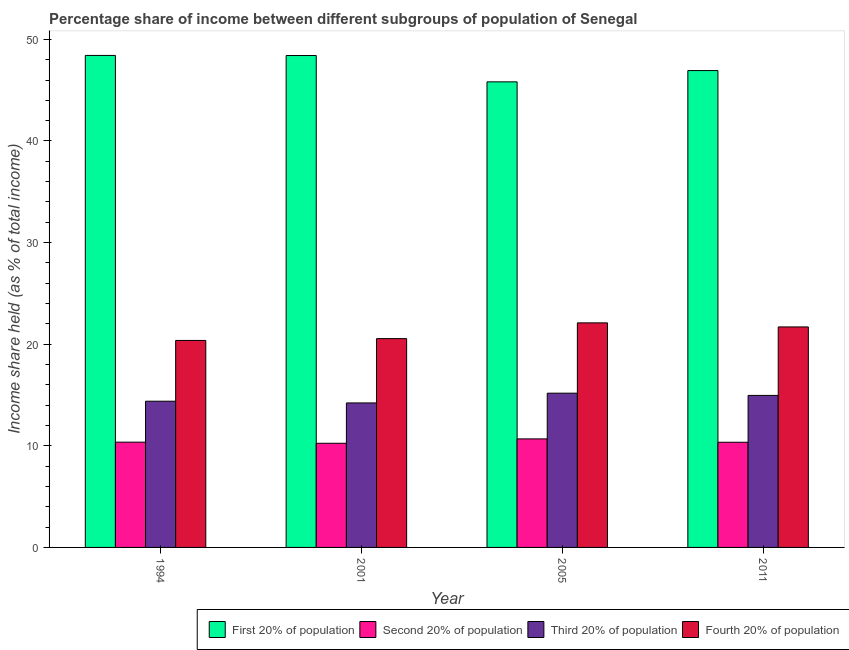How many different coloured bars are there?
Provide a short and direct response. 4. How many groups of bars are there?
Your answer should be compact. 4. Are the number of bars on each tick of the X-axis equal?
Ensure brevity in your answer.  Yes. How many bars are there on the 3rd tick from the left?
Make the answer very short. 4. How many bars are there on the 2nd tick from the right?
Your answer should be compact. 4. What is the label of the 3rd group of bars from the left?
Offer a very short reply. 2005. In how many cases, is the number of bars for a given year not equal to the number of legend labels?
Keep it short and to the point. 0. What is the share of the income held by fourth 20% of the population in 2001?
Give a very brief answer. 20.55. Across all years, what is the maximum share of the income held by second 20% of the population?
Ensure brevity in your answer.  10.68. Across all years, what is the minimum share of the income held by first 20% of the population?
Provide a succinct answer. 45.82. What is the total share of the income held by fourth 20% of the population in the graph?
Your answer should be compact. 84.72. What is the difference between the share of the income held by third 20% of the population in 1994 and that in 2005?
Provide a short and direct response. -0.79. What is the difference between the share of the income held by fourth 20% of the population in 2005 and the share of the income held by first 20% of the population in 2011?
Your answer should be very brief. 0.4. What is the average share of the income held by second 20% of the population per year?
Provide a succinct answer. 10.41. In how many years, is the share of the income held by first 20% of the population greater than 38 %?
Provide a succinct answer. 4. What is the ratio of the share of the income held by fourth 20% of the population in 1994 to that in 2005?
Provide a short and direct response. 0.92. Is the share of the income held by fourth 20% of the population in 1994 less than that in 2005?
Ensure brevity in your answer.  Yes. What is the difference between the highest and the second highest share of the income held by first 20% of the population?
Your response must be concise. 0.01. What is the difference between the highest and the lowest share of the income held by fourth 20% of the population?
Your answer should be very brief. 1.73. Is it the case that in every year, the sum of the share of the income held by first 20% of the population and share of the income held by third 20% of the population is greater than the sum of share of the income held by fourth 20% of the population and share of the income held by second 20% of the population?
Offer a very short reply. Yes. What does the 1st bar from the left in 1994 represents?
Make the answer very short. First 20% of population. What does the 4th bar from the right in 1994 represents?
Give a very brief answer. First 20% of population. What is the difference between two consecutive major ticks on the Y-axis?
Make the answer very short. 10. Are the values on the major ticks of Y-axis written in scientific E-notation?
Provide a short and direct response. No. Does the graph contain grids?
Ensure brevity in your answer.  No. What is the title of the graph?
Provide a succinct answer. Percentage share of income between different subgroups of population of Senegal. Does "UNTA" appear as one of the legend labels in the graph?
Keep it short and to the point. No. What is the label or title of the Y-axis?
Provide a succinct answer. Income share held (as % of total income). What is the Income share held (as % of total income) in First 20% of population in 1994?
Make the answer very short. 48.42. What is the Income share held (as % of total income) in Second 20% of population in 1994?
Offer a terse response. 10.36. What is the Income share held (as % of total income) of Third 20% of population in 1994?
Your answer should be compact. 14.39. What is the Income share held (as % of total income) in Fourth 20% of population in 1994?
Your answer should be very brief. 20.37. What is the Income share held (as % of total income) of First 20% of population in 2001?
Your answer should be compact. 48.41. What is the Income share held (as % of total income) of Second 20% of population in 2001?
Offer a very short reply. 10.25. What is the Income share held (as % of total income) in Third 20% of population in 2001?
Give a very brief answer. 14.22. What is the Income share held (as % of total income) of Fourth 20% of population in 2001?
Your answer should be very brief. 20.55. What is the Income share held (as % of total income) of First 20% of population in 2005?
Provide a short and direct response. 45.82. What is the Income share held (as % of total income) of Second 20% of population in 2005?
Ensure brevity in your answer.  10.68. What is the Income share held (as % of total income) in Third 20% of population in 2005?
Offer a very short reply. 15.18. What is the Income share held (as % of total income) of Fourth 20% of population in 2005?
Ensure brevity in your answer.  22.1. What is the Income share held (as % of total income) in First 20% of population in 2011?
Provide a short and direct response. 46.93. What is the Income share held (as % of total income) in Second 20% of population in 2011?
Provide a succinct answer. 10.35. What is the Income share held (as % of total income) in Third 20% of population in 2011?
Your answer should be compact. 14.96. What is the Income share held (as % of total income) of Fourth 20% of population in 2011?
Offer a very short reply. 21.7. Across all years, what is the maximum Income share held (as % of total income) in First 20% of population?
Give a very brief answer. 48.42. Across all years, what is the maximum Income share held (as % of total income) of Second 20% of population?
Provide a succinct answer. 10.68. Across all years, what is the maximum Income share held (as % of total income) in Third 20% of population?
Your answer should be compact. 15.18. Across all years, what is the maximum Income share held (as % of total income) in Fourth 20% of population?
Your response must be concise. 22.1. Across all years, what is the minimum Income share held (as % of total income) of First 20% of population?
Provide a succinct answer. 45.82. Across all years, what is the minimum Income share held (as % of total income) of Second 20% of population?
Provide a succinct answer. 10.25. Across all years, what is the minimum Income share held (as % of total income) of Third 20% of population?
Give a very brief answer. 14.22. Across all years, what is the minimum Income share held (as % of total income) in Fourth 20% of population?
Keep it short and to the point. 20.37. What is the total Income share held (as % of total income) of First 20% of population in the graph?
Offer a very short reply. 189.58. What is the total Income share held (as % of total income) of Second 20% of population in the graph?
Give a very brief answer. 41.64. What is the total Income share held (as % of total income) of Third 20% of population in the graph?
Your response must be concise. 58.75. What is the total Income share held (as % of total income) of Fourth 20% of population in the graph?
Your answer should be compact. 84.72. What is the difference between the Income share held (as % of total income) in Second 20% of population in 1994 and that in 2001?
Provide a succinct answer. 0.11. What is the difference between the Income share held (as % of total income) in Third 20% of population in 1994 and that in 2001?
Your response must be concise. 0.17. What is the difference between the Income share held (as % of total income) of Fourth 20% of population in 1994 and that in 2001?
Keep it short and to the point. -0.18. What is the difference between the Income share held (as % of total income) in First 20% of population in 1994 and that in 2005?
Give a very brief answer. 2.6. What is the difference between the Income share held (as % of total income) in Second 20% of population in 1994 and that in 2005?
Keep it short and to the point. -0.32. What is the difference between the Income share held (as % of total income) in Third 20% of population in 1994 and that in 2005?
Offer a very short reply. -0.79. What is the difference between the Income share held (as % of total income) of Fourth 20% of population in 1994 and that in 2005?
Your response must be concise. -1.73. What is the difference between the Income share held (as % of total income) of First 20% of population in 1994 and that in 2011?
Offer a very short reply. 1.49. What is the difference between the Income share held (as % of total income) in Second 20% of population in 1994 and that in 2011?
Ensure brevity in your answer.  0.01. What is the difference between the Income share held (as % of total income) in Third 20% of population in 1994 and that in 2011?
Keep it short and to the point. -0.57. What is the difference between the Income share held (as % of total income) of Fourth 20% of population in 1994 and that in 2011?
Make the answer very short. -1.33. What is the difference between the Income share held (as % of total income) in First 20% of population in 2001 and that in 2005?
Your answer should be compact. 2.59. What is the difference between the Income share held (as % of total income) in Second 20% of population in 2001 and that in 2005?
Provide a short and direct response. -0.43. What is the difference between the Income share held (as % of total income) in Third 20% of population in 2001 and that in 2005?
Offer a terse response. -0.96. What is the difference between the Income share held (as % of total income) of Fourth 20% of population in 2001 and that in 2005?
Provide a succinct answer. -1.55. What is the difference between the Income share held (as % of total income) in First 20% of population in 2001 and that in 2011?
Offer a very short reply. 1.48. What is the difference between the Income share held (as % of total income) of Second 20% of population in 2001 and that in 2011?
Offer a very short reply. -0.1. What is the difference between the Income share held (as % of total income) in Third 20% of population in 2001 and that in 2011?
Ensure brevity in your answer.  -0.74. What is the difference between the Income share held (as % of total income) in Fourth 20% of population in 2001 and that in 2011?
Your response must be concise. -1.15. What is the difference between the Income share held (as % of total income) in First 20% of population in 2005 and that in 2011?
Offer a terse response. -1.11. What is the difference between the Income share held (as % of total income) of Second 20% of population in 2005 and that in 2011?
Provide a succinct answer. 0.33. What is the difference between the Income share held (as % of total income) of Third 20% of population in 2005 and that in 2011?
Your response must be concise. 0.22. What is the difference between the Income share held (as % of total income) of First 20% of population in 1994 and the Income share held (as % of total income) of Second 20% of population in 2001?
Keep it short and to the point. 38.17. What is the difference between the Income share held (as % of total income) in First 20% of population in 1994 and the Income share held (as % of total income) in Third 20% of population in 2001?
Your answer should be very brief. 34.2. What is the difference between the Income share held (as % of total income) in First 20% of population in 1994 and the Income share held (as % of total income) in Fourth 20% of population in 2001?
Offer a very short reply. 27.87. What is the difference between the Income share held (as % of total income) in Second 20% of population in 1994 and the Income share held (as % of total income) in Third 20% of population in 2001?
Your answer should be compact. -3.86. What is the difference between the Income share held (as % of total income) in Second 20% of population in 1994 and the Income share held (as % of total income) in Fourth 20% of population in 2001?
Provide a short and direct response. -10.19. What is the difference between the Income share held (as % of total income) of Third 20% of population in 1994 and the Income share held (as % of total income) of Fourth 20% of population in 2001?
Make the answer very short. -6.16. What is the difference between the Income share held (as % of total income) of First 20% of population in 1994 and the Income share held (as % of total income) of Second 20% of population in 2005?
Your answer should be very brief. 37.74. What is the difference between the Income share held (as % of total income) of First 20% of population in 1994 and the Income share held (as % of total income) of Third 20% of population in 2005?
Give a very brief answer. 33.24. What is the difference between the Income share held (as % of total income) of First 20% of population in 1994 and the Income share held (as % of total income) of Fourth 20% of population in 2005?
Your answer should be compact. 26.32. What is the difference between the Income share held (as % of total income) of Second 20% of population in 1994 and the Income share held (as % of total income) of Third 20% of population in 2005?
Offer a terse response. -4.82. What is the difference between the Income share held (as % of total income) in Second 20% of population in 1994 and the Income share held (as % of total income) in Fourth 20% of population in 2005?
Offer a terse response. -11.74. What is the difference between the Income share held (as % of total income) of Third 20% of population in 1994 and the Income share held (as % of total income) of Fourth 20% of population in 2005?
Your answer should be very brief. -7.71. What is the difference between the Income share held (as % of total income) of First 20% of population in 1994 and the Income share held (as % of total income) of Second 20% of population in 2011?
Your response must be concise. 38.07. What is the difference between the Income share held (as % of total income) of First 20% of population in 1994 and the Income share held (as % of total income) of Third 20% of population in 2011?
Give a very brief answer. 33.46. What is the difference between the Income share held (as % of total income) of First 20% of population in 1994 and the Income share held (as % of total income) of Fourth 20% of population in 2011?
Make the answer very short. 26.72. What is the difference between the Income share held (as % of total income) in Second 20% of population in 1994 and the Income share held (as % of total income) in Fourth 20% of population in 2011?
Provide a short and direct response. -11.34. What is the difference between the Income share held (as % of total income) of Third 20% of population in 1994 and the Income share held (as % of total income) of Fourth 20% of population in 2011?
Provide a succinct answer. -7.31. What is the difference between the Income share held (as % of total income) of First 20% of population in 2001 and the Income share held (as % of total income) of Second 20% of population in 2005?
Ensure brevity in your answer.  37.73. What is the difference between the Income share held (as % of total income) of First 20% of population in 2001 and the Income share held (as % of total income) of Third 20% of population in 2005?
Provide a short and direct response. 33.23. What is the difference between the Income share held (as % of total income) of First 20% of population in 2001 and the Income share held (as % of total income) of Fourth 20% of population in 2005?
Your answer should be compact. 26.31. What is the difference between the Income share held (as % of total income) of Second 20% of population in 2001 and the Income share held (as % of total income) of Third 20% of population in 2005?
Ensure brevity in your answer.  -4.93. What is the difference between the Income share held (as % of total income) in Second 20% of population in 2001 and the Income share held (as % of total income) in Fourth 20% of population in 2005?
Your answer should be compact. -11.85. What is the difference between the Income share held (as % of total income) in Third 20% of population in 2001 and the Income share held (as % of total income) in Fourth 20% of population in 2005?
Offer a very short reply. -7.88. What is the difference between the Income share held (as % of total income) in First 20% of population in 2001 and the Income share held (as % of total income) in Second 20% of population in 2011?
Offer a very short reply. 38.06. What is the difference between the Income share held (as % of total income) in First 20% of population in 2001 and the Income share held (as % of total income) in Third 20% of population in 2011?
Ensure brevity in your answer.  33.45. What is the difference between the Income share held (as % of total income) of First 20% of population in 2001 and the Income share held (as % of total income) of Fourth 20% of population in 2011?
Your answer should be very brief. 26.71. What is the difference between the Income share held (as % of total income) of Second 20% of population in 2001 and the Income share held (as % of total income) of Third 20% of population in 2011?
Your response must be concise. -4.71. What is the difference between the Income share held (as % of total income) of Second 20% of population in 2001 and the Income share held (as % of total income) of Fourth 20% of population in 2011?
Offer a very short reply. -11.45. What is the difference between the Income share held (as % of total income) in Third 20% of population in 2001 and the Income share held (as % of total income) in Fourth 20% of population in 2011?
Offer a terse response. -7.48. What is the difference between the Income share held (as % of total income) of First 20% of population in 2005 and the Income share held (as % of total income) of Second 20% of population in 2011?
Provide a succinct answer. 35.47. What is the difference between the Income share held (as % of total income) in First 20% of population in 2005 and the Income share held (as % of total income) in Third 20% of population in 2011?
Your answer should be compact. 30.86. What is the difference between the Income share held (as % of total income) in First 20% of population in 2005 and the Income share held (as % of total income) in Fourth 20% of population in 2011?
Your response must be concise. 24.12. What is the difference between the Income share held (as % of total income) of Second 20% of population in 2005 and the Income share held (as % of total income) of Third 20% of population in 2011?
Offer a terse response. -4.28. What is the difference between the Income share held (as % of total income) in Second 20% of population in 2005 and the Income share held (as % of total income) in Fourth 20% of population in 2011?
Your answer should be compact. -11.02. What is the difference between the Income share held (as % of total income) in Third 20% of population in 2005 and the Income share held (as % of total income) in Fourth 20% of population in 2011?
Provide a short and direct response. -6.52. What is the average Income share held (as % of total income) in First 20% of population per year?
Provide a succinct answer. 47.4. What is the average Income share held (as % of total income) of Second 20% of population per year?
Make the answer very short. 10.41. What is the average Income share held (as % of total income) of Third 20% of population per year?
Your response must be concise. 14.69. What is the average Income share held (as % of total income) of Fourth 20% of population per year?
Your answer should be compact. 21.18. In the year 1994, what is the difference between the Income share held (as % of total income) of First 20% of population and Income share held (as % of total income) of Second 20% of population?
Ensure brevity in your answer.  38.06. In the year 1994, what is the difference between the Income share held (as % of total income) of First 20% of population and Income share held (as % of total income) of Third 20% of population?
Provide a short and direct response. 34.03. In the year 1994, what is the difference between the Income share held (as % of total income) in First 20% of population and Income share held (as % of total income) in Fourth 20% of population?
Provide a short and direct response. 28.05. In the year 1994, what is the difference between the Income share held (as % of total income) in Second 20% of population and Income share held (as % of total income) in Third 20% of population?
Keep it short and to the point. -4.03. In the year 1994, what is the difference between the Income share held (as % of total income) in Second 20% of population and Income share held (as % of total income) in Fourth 20% of population?
Offer a terse response. -10.01. In the year 1994, what is the difference between the Income share held (as % of total income) in Third 20% of population and Income share held (as % of total income) in Fourth 20% of population?
Make the answer very short. -5.98. In the year 2001, what is the difference between the Income share held (as % of total income) of First 20% of population and Income share held (as % of total income) of Second 20% of population?
Keep it short and to the point. 38.16. In the year 2001, what is the difference between the Income share held (as % of total income) in First 20% of population and Income share held (as % of total income) in Third 20% of population?
Your response must be concise. 34.19. In the year 2001, what is the difference between the Income share held (as % of total income) in First 20% of population and Income share held (as % of total income) in Fourth 20% of population?
Offer a terse response. 27.86. In the year 2001, what is the difference between the Income share held (as % of total income) of Second 20% of population and Income share held (as % of total income) of Third 20% of population?
Provide a succinct answer. -3.97. In the year 2001, what is the difference between the Income share held (as % of total income) of Second 20% of population and Income share held (as % of total income) of Fourth 20% of population?
Your response must be concise. -10.3. In the year 2001, what is the difference between the Income share held (as % of total income) in Third 20% of population and Income share held (as % of total income) in Fourth 20% of population?
Offer a very short reply. -6.33. In the year 2005, what is the difference between the Income share held (as % of total income) in First 20% of population and Income share held (as % of total income) in Second 20% of population?
Your answer should be compact. 35.14. In the year 2005, what is the difference between the Income share held (as % of total income) in First 20% of population and Income share held (as % of total income) in Third 20% of population?
Provide a short and direct response. 30.64. In the year 2005, what is the difference between the Income share held (as % of total income) of First 20% of population and Income share held (as % of total income) of Fourth 20% of population?
Your response must be concise. 23.72. In the year 2005, what is the difference between the Income share held (as % of total income) of Second 20% of population and Income share held (as % of total income) of Third 20% of population?
Ensure brevity in your answer.  -4.5. In the year 2005, what is the difference between the Income share held (as % of total income) of Second 20% of population and Income share held (as % of total income) of Fourth 20% of population?
Make the answer very short. -11.42. In the year 2005, what is the difference between the Income share held (as % of total income) of Third 20% of population and Income share held (as % of total income) of Fourth 20% of population?
Provide a short and direct response. -6.92. In the year 2011, what is the difference between the Income share held (as % of total income) of First 20% of population and Income share held (as % of total income) of Second 20% of population?
Offer a very short reply. 36.58. In the year 2011, what is the difference between the Income share held (as % of total income) in First 20% of population and Income share held (as % of total income) in Third 20% of population?
Ensure brevity in your answer.  31.97. In the year 2011, what is the difference between the Income share held (as % of total income) of First 20% of population and Income share held (as % of total income) of Fourth 20% of population?
Make the answer very short. 25.23. In the year 2011, what is the difference between the Income share held (as % of total income) in Second 20% of population and Income share held (as % of total income) in Third 20% of population?
Your answer should be very brief. -4.61. In the year 2011, what is the difference between the Income share held (as % of total income) in Second 20% of population and Income share held (as % of total income) in Fourth 20% of population?
Provide a succinct answer. -11.35. In the year 2011, what is the difference between the Income share held (as % of total income) of Third 20% of population and Income share held (as % of total income) of Fourth 20% of population?
Your answer should be very brief. -6.74. What is the ratio of the Income share held (as % of total income) of First 20% of population in 1994 to that in 2001?
Give a very brief answer. 1. What is the ratio of the Income share held (as % of total income) in Second 20% of population in 1994 to that in 2001?
Keep it short and to the point. 1.01. What is the ratio of the Income share held (as % of total income) in Fourth 20% of population in 1994 to that in 2001?
Your answer should be very brief. 0.99. What is the ratio of the Income share held (as % of total income) of First 20% of population in 1994 to that in 2005?
Your answer should be very brief. 1.06. What is the ratio of the Income share held (as % of total income) of Second 20% of population in 1994 to that in 2005?
Your answer should be very brief. 0.97. What is the ratio of the Income share held (as % of total income) in Third 20% of population in 1994 to that in 2005?
Your answer should be compact. 0.95. What is the ratio of the Income share held (as % of total income) in Fourth 20% of population in 1994 to that in 2005?
Ensure brevity in your answer.  0.92. What is the ratio of the Income share held (as % of total income) in First 20% of population in 1994 to that in 2011?
Ensure brevity in your answer.  1.03. What is the ratio of the Income share held (as % of total income) in Second 20% of population in 1994 to that in 2011?
Give a very brief answer. 1. What is the ratio of the Income share held (as % of total income) in Third 20% of population in 1994 to that in 2011?
Your response must be concise. 0.96. What is the ratio of the Income share held (as % of total income) of Fourth 20% of population in 1994 to that in 2011?
Ensure brevity in your answer.  0.94. What is the ratio of the Income share held (as % of total income) of First 20% of population in 2001 to that in 2005?
Offer a terse response. 1.06. What is the ratio of the Income share held (as % of total income) of Second 20% of population in 2001 to that in 2005?
Provide a succinct answer. 0.96. What is the ratio of the Income share held (as % of total income) in Third 20% of population in 2001 to that in 2005?
Keep it short and to the point. 0.94. What is the ratio of the Income share held (as % of total income) of Fourth 20% of population in 2001 to that in 2005?
Make the answer very short. 0.93. What is the ratio of the Income share held (as % of total income) in First 20% of population in 2001 to that in 2011?
Your response must be concise. 1.03. What is the ratio of the Income share held (as % of total income) in Second 20% of population in 2001 to that in 2011?
Provide a succinct answer. 0.99. What is the ratio of the Income share held (as % of total income) of Third 20% of population in 2001 to that in 2011?
Offer a very short reply. 0.95. What is the ratio of the Income share held (as % of total income) in Fourth 20% of population in 2001 to that in 2011?
Your answer should be compact. 0.95. What is the ratio of the Income share held (as % of total income) in First 20% of population in 2005 to that in 2011?
Offer a very short reply. 0.98. What is the ratio of the Income share held (as % of total income) in Second 20% of population in 2005 to that in 2011?
Keep it short and to the point. 1.03. What is the ratio of the Income share held (as % of total income) of Third 20% of population in 2005 to that in 2011?
Your response must be concise. 1.01. What is the ratio of the Income share held (as % of total income) of Fourth 20% of population in 2005 to that in 2011?
Offer a terse response. 1.02. What is the difference between the highest and the second highest Income share held (as % of total income) in Second 20% of population?
Ensure brevity in your answer.  0.32. What is the difference between the highest and the second highest Income share held (as % of total income) in Third 20% of population?
Ensure brevity in your answer.  0.22. What is the difference between the highest and the second highest Income share held (as % of total income) of Fourth 20% of population?
Your response must be concise. 0.4. What is the difference between the highest and the lowest Income share held (as % of total income) in Second 20% of population?
Make the answer very short. 0.43. What is the difference between the highest and the lowest Income share held (as % of total income) in Fourth 20% of population?
Offer a terse response. 1.73. 